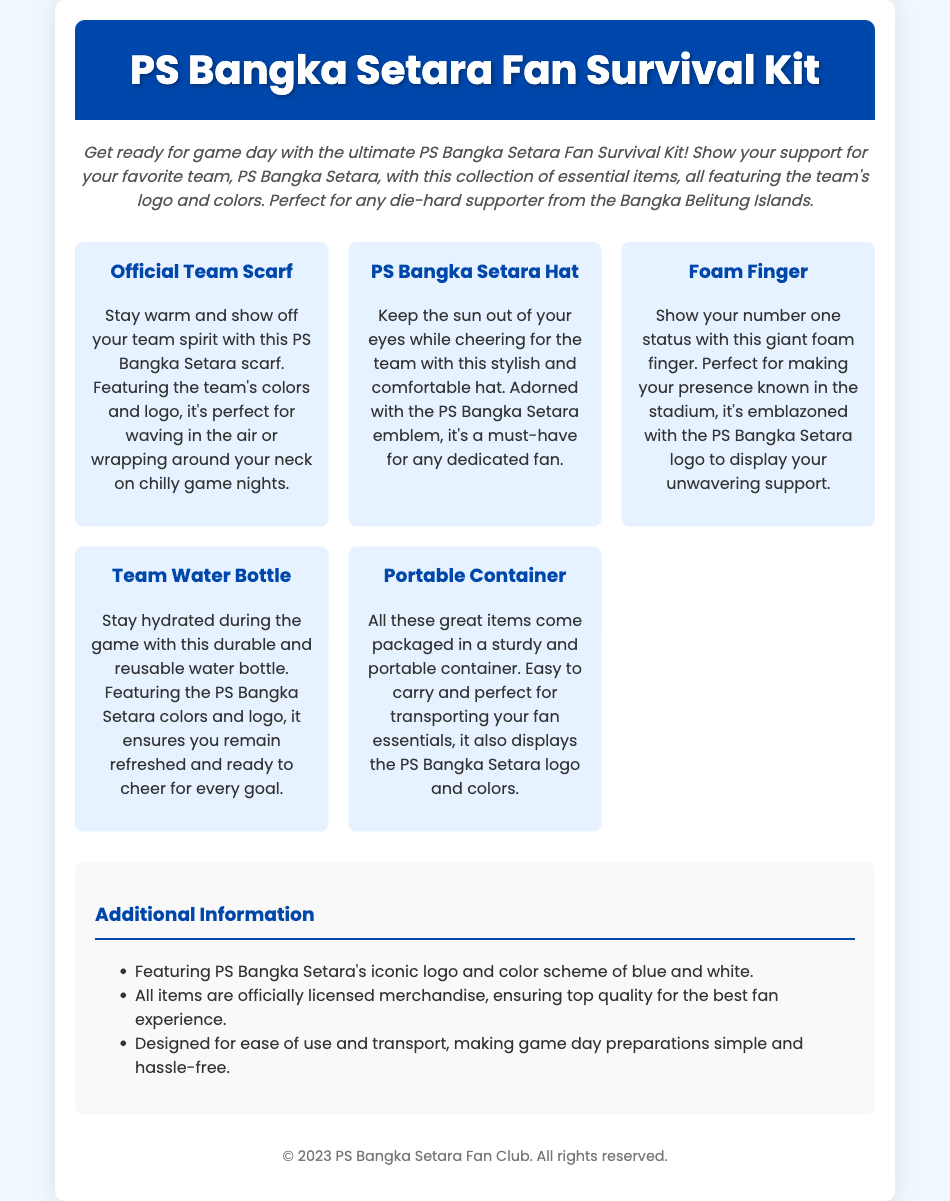What does the kit contain? The kit contains an Official Team Scarf, PS Bangka Setara Hat, Foam Finger, Team Water Bottle, and Portable Container.
Answer: Official Team Scarf, PS Bangka Setara Hat, Foam Finger, Team Water Bottle, Portable Container What colors are used in the kit? The colors used in the kit are blue and white, as mentioned in the additional information section.
Answer: Blue and white What is the purpose of the Portable Container? The Portable Container is designed for easy transport of fan essentials, as stated in the description of the kit items.
Answer: Easy transport How many items are listed in the kit? The kit lists five essential items for fans, making it easy to count.
Answer: Five Is the merchandise officially licensed? The additional information section confirms that all items are officially licensed merchandise.
Answer: Yes What is the size of the text for the kit title? The title font size is indicated in the document's CSS as 2.5em.
Answer: 2.5em What does the foam finger represent? The foam finger represents showing number one status and team support at the stadium, as described in its item detail.
Answer: Number one status What type of product is this document for? This document is for a product called the "PS Bangka Setara Fan Survival Kit."
Answer: Fan Survival Kit Who is the target audience for this kit? The target audience is die-hard supporters of PS Bangka Setara, particularly fans from the Bangka Belitung Islands, as seen in the introduction.
Answer: Die-hard supporters of PS Bangka Setara 